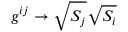<formula> <loc_0><loc_0><loc_500><loc_500>g ^ { i j } \rightarrow \sqrt { S _ { j } } \sqrt { S _ { i } }</formula> 